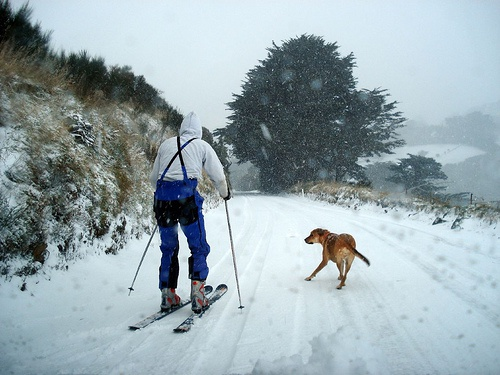Describe the objects in this image and their specific colors. I can see people in teal, navy, black, darkgray, and lightgray tones, dog in teal, maroon, gray, and tan tones, and skis in teal, darkgray, black, and gray tones in this image. 